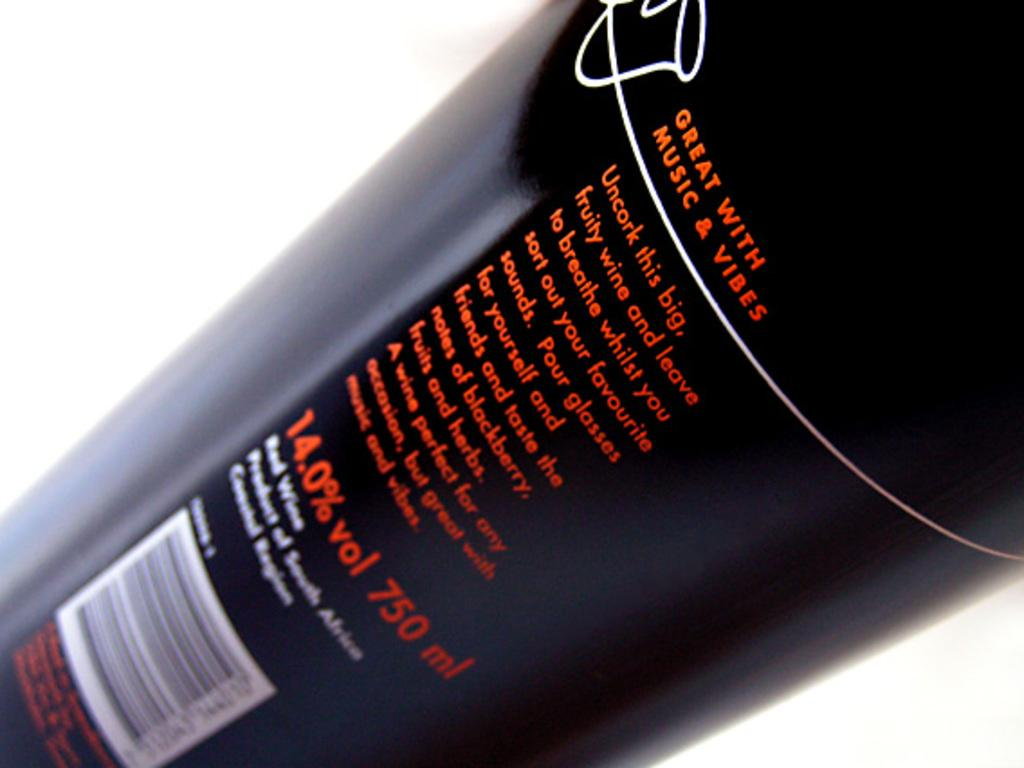<image>
Present a compact description of the photo's key features. A bottle of red wine which is apparently Great with Music and Vibes. 